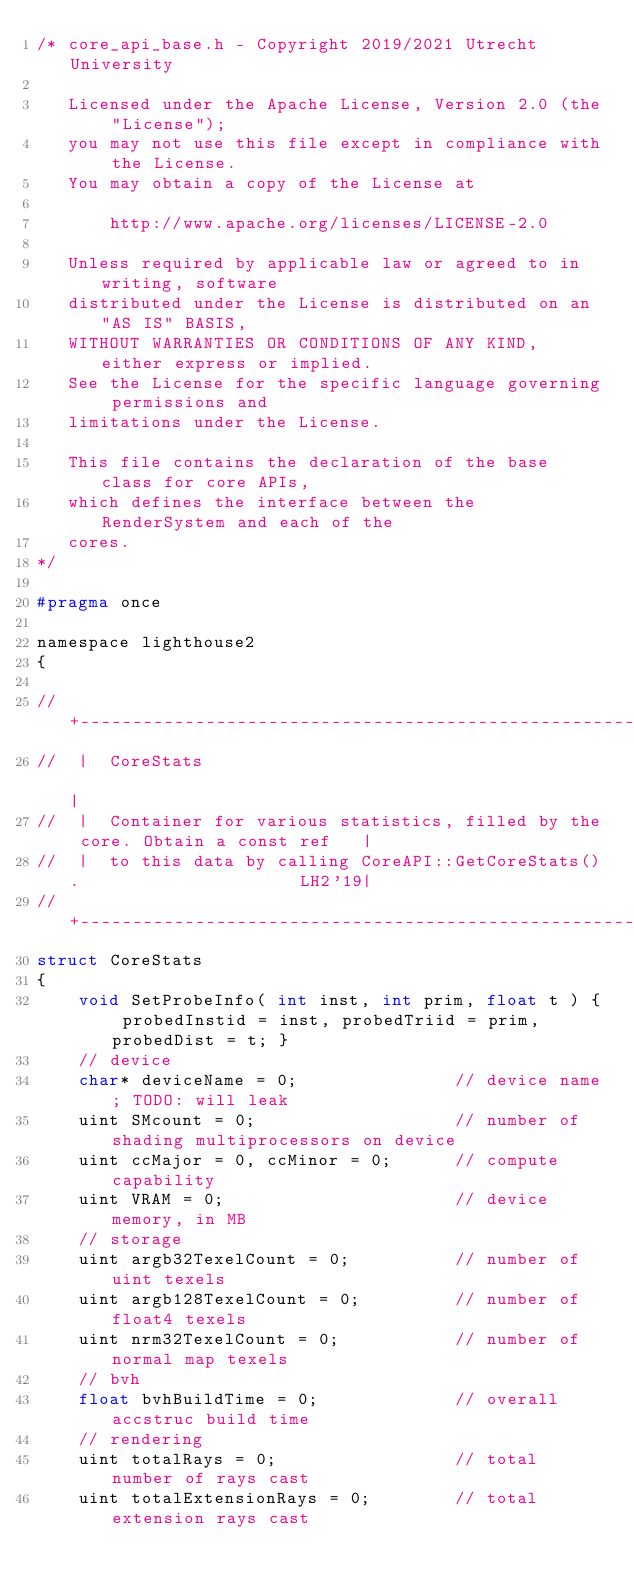Convert code to text. <code><loc_0><loc_0><loc_500><loc_500><_C_>/* core_api_base.h - Copyright 2019/2021 Utrecht University

   Licensed under the Apache License, Version 2.0 (the "License");
   you may not use this file except in compliance with the License.
   You may obtain a copy of the License at

	   http://www.apache.org/licenses/LICENSE-2.0

   Unless required by applicable law or agreed to in writing, software
   distributed under the License is distributed on an "AS IS" BASIS,
   WITHOUT WARRANTIES OR CONDITIONS OF ANY KIND, either express or implied.
   See the License for the specific language governing permissions and
   limitations under the License.

   This file contains the declaration of the base class for core APIs,
   which defines the interface between the RenderSystem and each of the
   cores.
*/

#pragma once

namespace lighthouse2
{

//  +-----------------------------------------------------------------------------+
//  |  CoreStats                                                                  |
//  |  Container for various statistics, filled by the core. Obtain a const ref   |
//  |  to this data by calling CoreAPI::GetCoreStats().                     LH2'19|
//  +-----------------------------------------------------------------------------+
struct CoreStats
{
	void SetProbeInfo( int inst, int prim, float t ) { probedInstid = inst, probedTriid = prim, probedDist = t; }
	// device
	char* deviceName = 0;				// device name; TODO: will leak
	uint SMcount = 0;					// number of shading multiprocessors on device
	uint ccMajor = 0, ccMinor = 0;		// compute capability
	uint VRAM = 0;						// device memory, in MB
	// storage
	uint argb32TexelCount = 0;			// number of uint texels
	uint argb128TexelCount = 0;			// number of float4 texels
	uint nrm32TexelCount = 0;			// number of normal map texels
	// bvh
	float bvhBuildTime = 0;				// overall accstruc build time
	// rendering
	uint totalRays = 0;					// total number of rays cast
	uint totalExtensionRays = 0;		// total extension rays cast</code> 